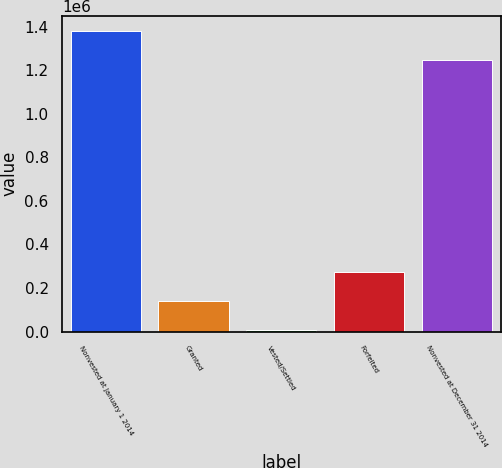Convert chart. <chart><loc_0><loc_0><loc_500><loc_500><bar_chart><fcel>Nonvested at January 1 2014<fcel>Granted<fcel>Vested/Settled<fcel>Forfeited<fcel>Nonvested at December 31 2014<nl><fcel>1.37926e+06<fcel>140543<fcel>5984<fcel>275102<fcel>1.2447e+06<nl></chart> 